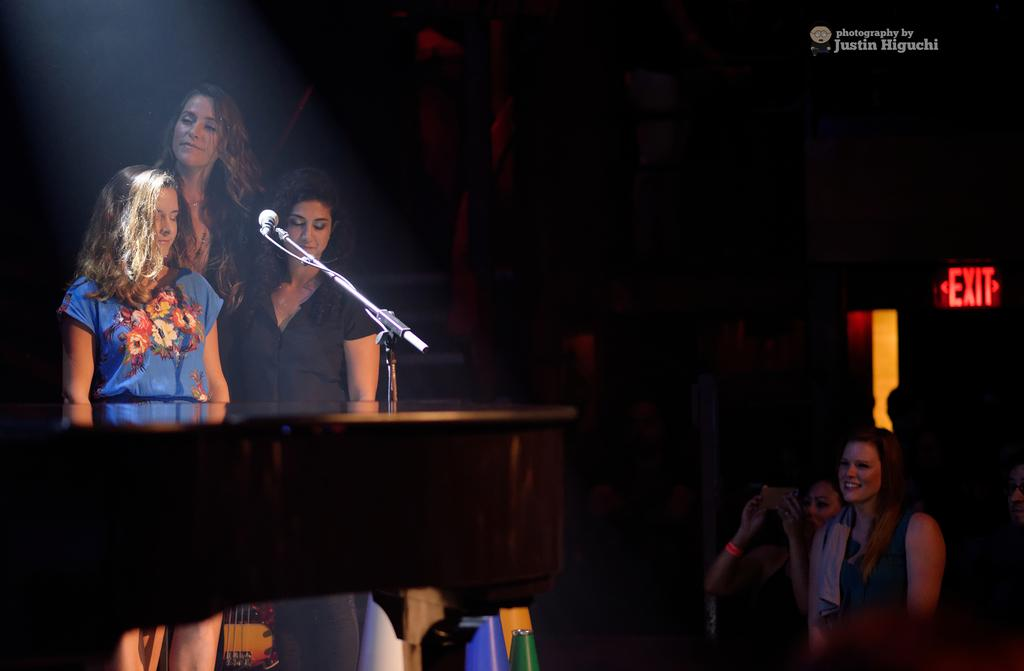How many women are present in the image? There are five women in the image. What are the women doing in the image? Three women are standing behind a mic, while two additional women are standing in front of the mic. What can be seen in front of the women? There is a mic in front of the women. What is the color of the background in the image? The background of the image is dark. What type of rub is being used by the women in the image? There is no rub present in the image; the women are standing near a mic. What form of communication are the women engaged in while standing near the mic? The image does not show the women talking or communicating in any way; they are simply standing near the mic. 